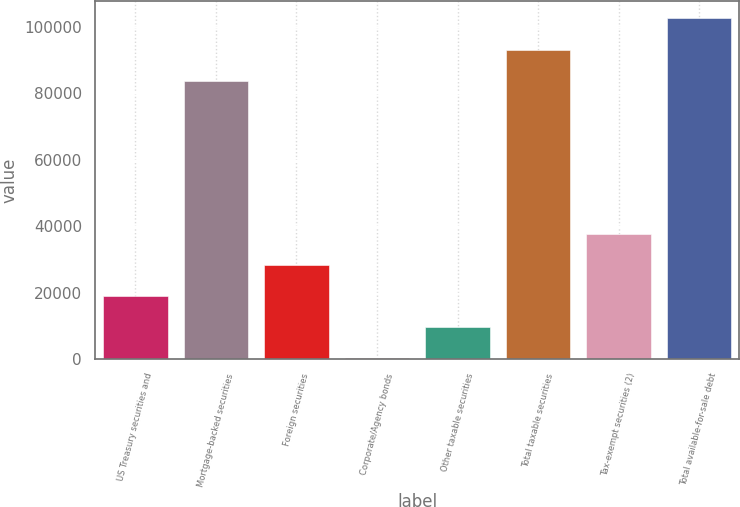Convert chart to OTSL. <chart><loc_0><loc_0><loc_500><loc_500><bar_chart><fcel>US Treasury securities and<fcel>Mortgage-backed securities<fcel>Foreign securities<fcel>Corporate/Agency bonds<fcel>Other taxable securities<fcel>Total taxable securities<fcel>Tax-exempt securities (2)<fcel>Total available-for-sale debt<nl><fcel>18951.4<fcel>83826<fcel>28334.6<fcel>185<fcel>9568.2<fcel>93209.2<fcel>37717.8<fcel>102592<nl></chart> 